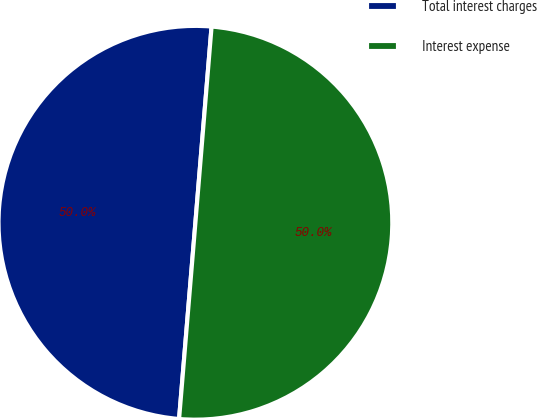<chart> <loc_0><loc_0><loc_500><loc_500><pie_chart><fcel>Total interest charges<fcel>Interest expense<nl><fcel>49.99%<fcel>50.01%<nl></chart> 